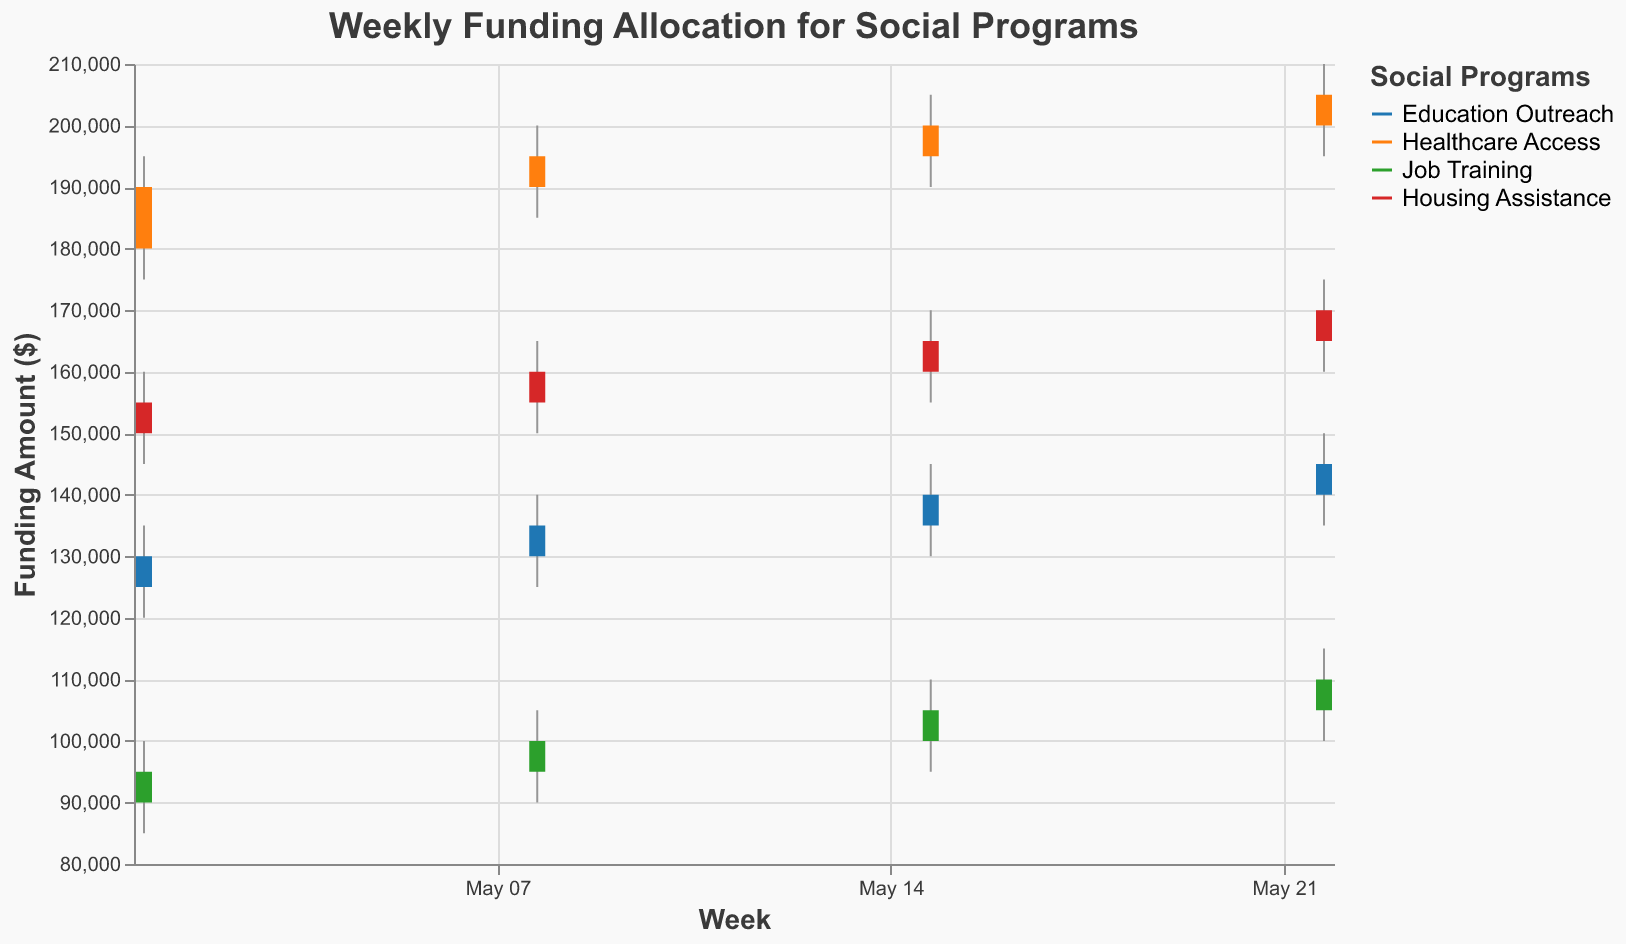What is the highest allocation for Healthcare Access in any week? The highest allocation can be found by looking for the maximum "High" value for "Healthcare Access". The highest value is $210,000 on the week of May 22, 2023.
Answer: $210,000 Which program saw the most significant increase in funding from the first to the last week? To determine the program with the most significant increase, compare the "Open" value of the first week to the "Close" value of the last week. Education Outreach increased from $125,000 to $145,000, Healthcare Access from $180,000 to $205,000, Job Training from $90,000 to $110,000, and Housing Assistance from $150,000 to $170,000. Healthcare Access saw the largest increase ($25,000).
Answer: Healthcare Access How many social programs are being tracked? The legend and the differing colors represent different social programs. There are four colors, one for each program: Education Outreach, Healthcare Access, Job Training, and Housing Assistance.
Answer: 4 Which week did Job Training receive the lowest funding in the "Low" category? Examine the "Low" values for Job Training across all weeks. The lowest "Low" value is $85,000 during the week of May 1, 2023.
Answer: May 1, 2023 During which week did Housing Assistance have the smallest range of funding? The range of funding is the difference between the "High" and "Low" values. For each week: 
- May 1: $160,000 - $145,000 = $15,000
- May 8: $165,000 - $150,000 = $15,000
- May 15: $170,000 - $155,000 = $15,000
- May 22: $175,000 - $160,000 = $15,000
Since all ranges are equal, Housing Assistance had a consistent range of $15,000 across all weeks.
Answer: All weeks Which program saw the least change in funding over the period analyzed? To determine the least change, compare the "Open" value of the first week to the "Close" value of the last week. Calculate the differences: 
- Education Outreach: $145,000 - $125,000 = $20,000
- Healthcare Access: $205,000 - $180,000 = $25,000
- Job Training: $110,000 - $90,000 = $20,000
- Housing Assistance: $170,000 - $150,000 = $20,000
Three programs (Education Outreach, Job Training, Housing Assistance) had equal least changes of $20,000.
Answer: Education Outreach, Job Training, Housing Assistance What is the average closing value for Education Outreach over the four weeks? To find the average, sum the "Close" values for Education Outreach and divide by the number of weeks: ($130,000 + $135,000 + $140,000 + $145,000) / 4 = $550,000 / 4 = $137,500.
Answer: $137,500 